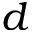<formula> <loc_0><loc_0><loc_500><loc_500>d</formula> 